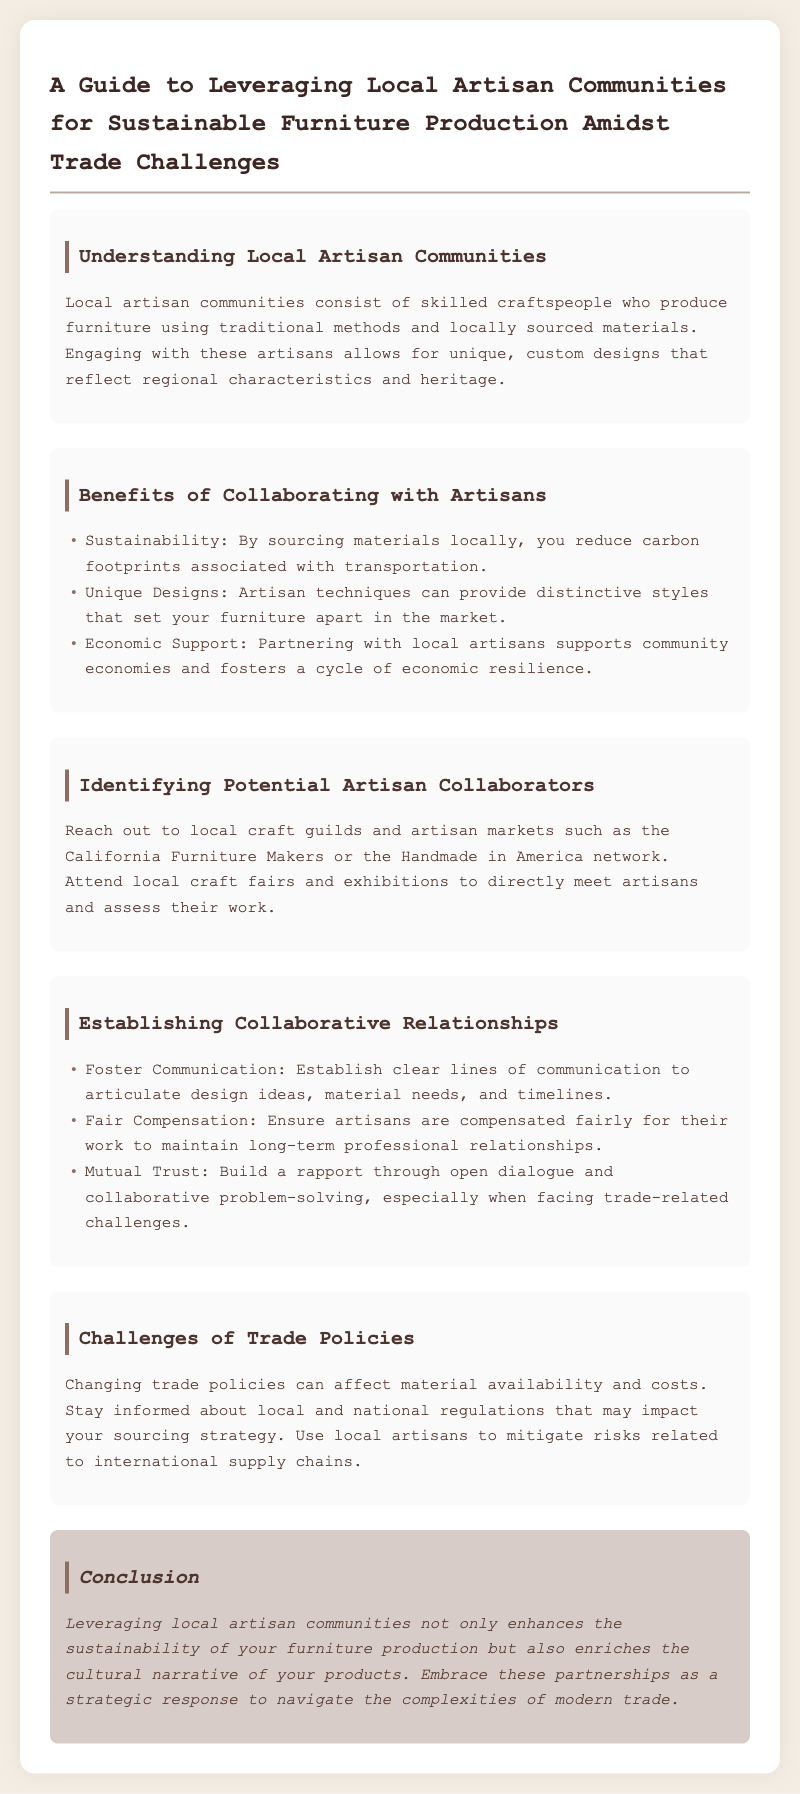What are local artisan communities? Local artisan communities consist of skilled craftspeople who produce furniture using traditional methods and locally sourced materials.
Answer: Skilled craftspeople What is one benefit of collaborating with artisans? One of the benefits listed in the document is that collaborating with artisans provides unique styles that set furniture apart.
Answer: Unique Designs What should be established for a successful collaboration? The document suggests that clear lines of communication should be established to discuss design ideas and other details for collaboration.
Answer: Communication Which network is mentioned as a way to identify artisan collaborators? The Handmade in America network is specifically mentioned as a way to identify potential artisan collaborators.
Answer: Handmade in America What challenge can affect material availability? Changing trade policies can affect the availability and costs of materials for furniture production.
Answer: Trade Policies How should artisans be compensated? The document states that artisans should be compensated fairly for their work to maintain professional relationships.
Answer: Fair Compensation What do artisan techniques provide for furniture? Artisan techniques provide distinctive styles that differentiate furniture in the market according to the document.
Answer: Distinctive styles What is a strategic response to trade complexities mentioned in the conclusion? The conclusion emphasizes embracing partnerships with local artisan communities as a strategic response to navigate trade complexities.
Answer: Partnerships with local artisan communities 